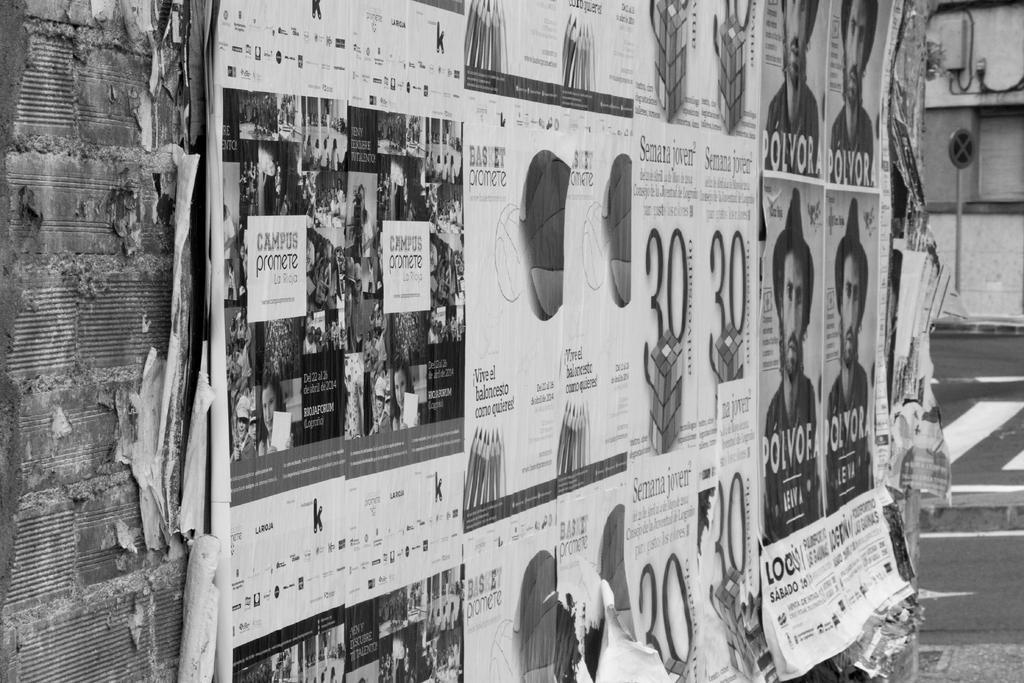Please provide a concise description of this image. This is a black and white image and here we can see posts on the wall and in the background, there is a pole and at the bottom, there is road. 